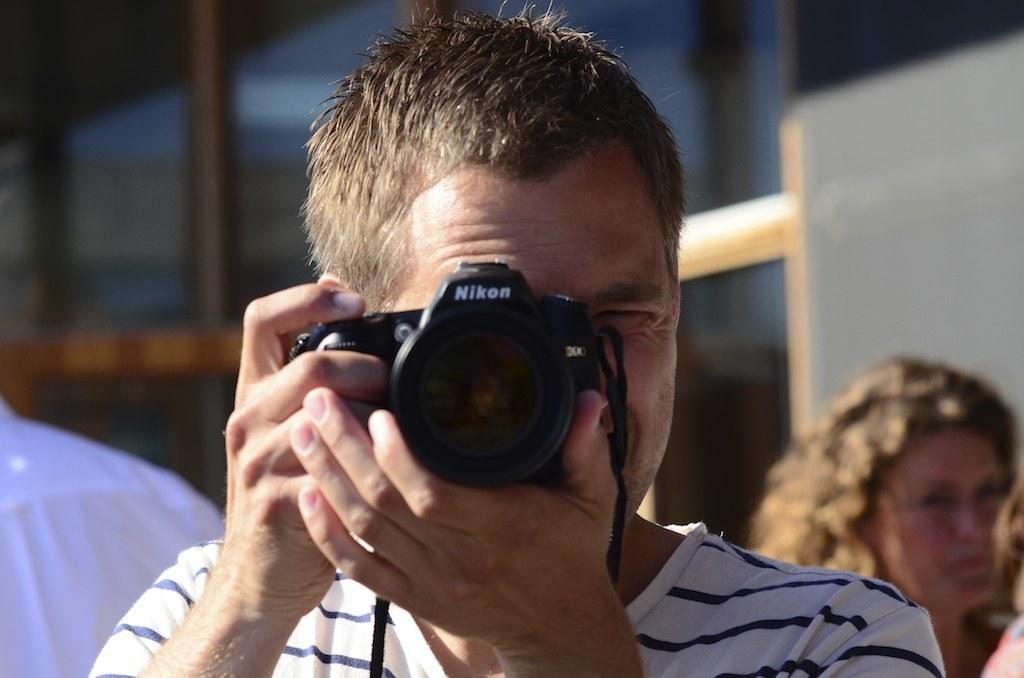In one or two sentences, can you explain what this image depicts? In this image I can see a man is holding a camera. In the background I can see few more people. 